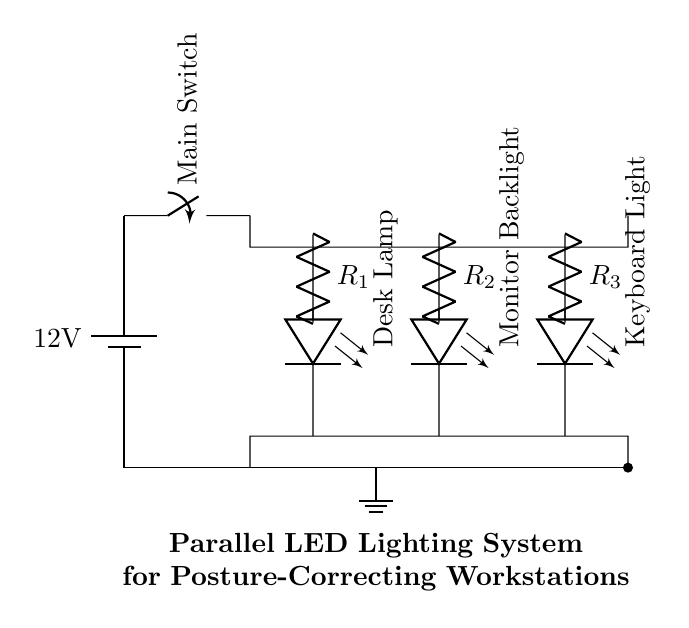What is the voltage of the power supply? The voltage of the power supply is indicated by the battery symbol on the circuit diagram, which clearly states it as 12 volts.
Answer: 12 volts What components are connected in parallel? The circuit shows three LEDs connected in parallel: Desk Lamp, Monitor Backlight, and Keyboard Light. They connect to the same voltage level across their terminals, representing parallel connection.
Answer: Desk Lamp, Monitor Backlight, Keyboard Light What is the function of the resistors in this circuit? The resistors are used to limit the current flowing through each LED. Each resistor is connected in series with its respective LED thereby controlling the amount of current that flows through that branch and ensuring safe operation of the LEDs.
Answer: Current limiting How many LEDs are in this circuit? The circuit diagram indicates that there are three LEDs present, each serving a different function related to workspace lighting.
Answer: Three What happens when the main switch is opened? When the main switch is opened, it creates an open circuit, which interrupts the flow of electricity from the power supply, causing all LEDs to turn off as there is no complete circuit for the current to flow.
Answer: All LEDs turn off What type of circuit is depicted in this diagram? The circuit is a parallel circuit configuration, as multiple components (LEDs) are connected across the same voltage supply and share the same voltage difference, allowing them to operate independently of each other.
Answer: Parallel circuit What would be the total current if each LED has a current of 20 mA? In a parallel circuit, the total current is the sum of the individual branch currents. Since there are three LEDs each drawing 20 mA, the total current would be 60 mA (20 mA + 20 mA + 20 mA).
Answer: 60 mA 